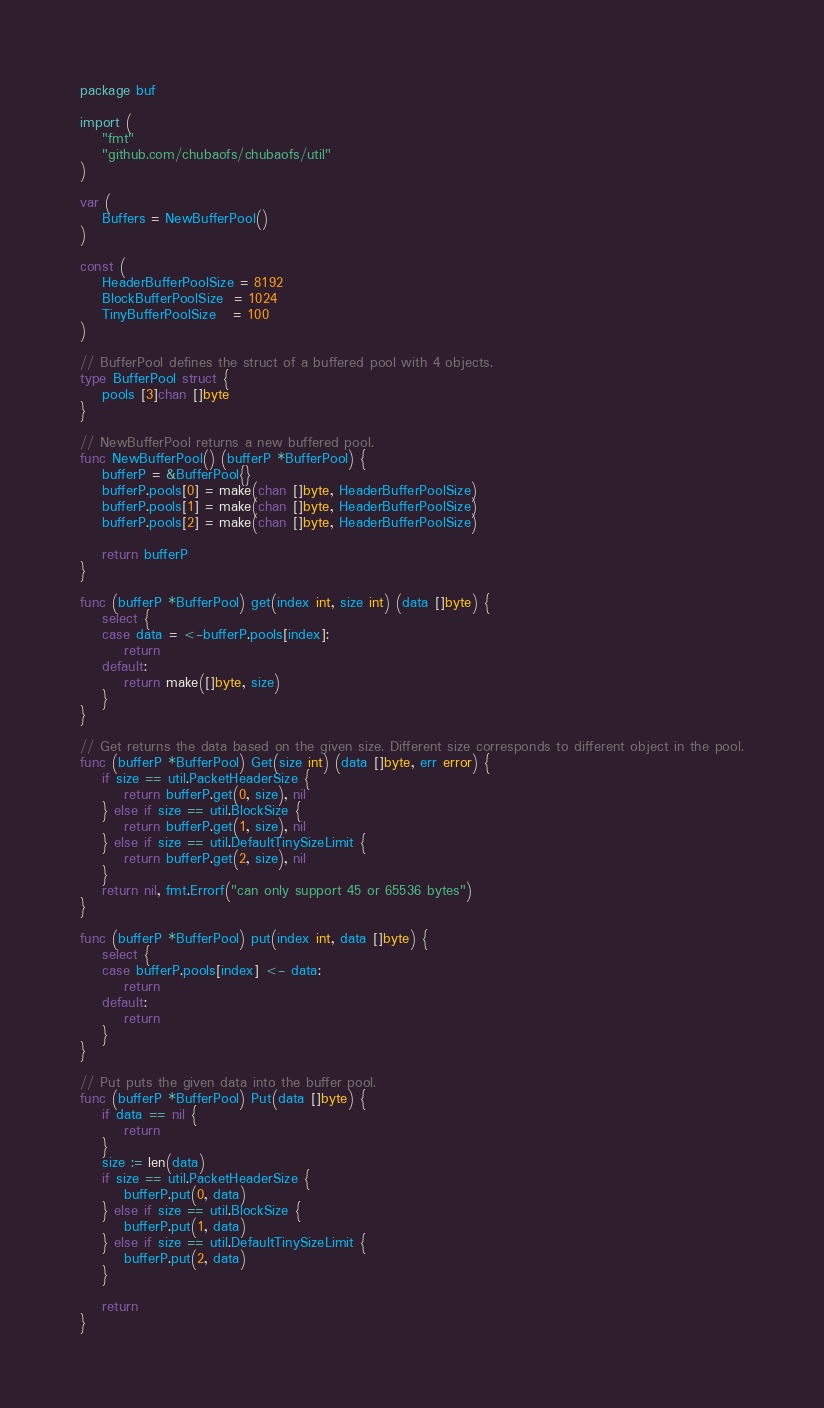Convert code to text. <code><loc_0><loc_0><loc_500><loc_500><_Go_>package buf

import (
	"fmt"
	"github.com/chubaofs/chubaofs/util"
)

var (
	Buffers = NewBufferPool()
)

const (
	HeaderBufferPoolSize = 8192
	BlockBufferPoolSize  = 1024
	TinyBufferPoolSize   = 100
)

// BufferPool defines the struct of a buffered pool with 4 objects.
type BufferPool struct {
	pools [3]chan []byte
}

// NewBufferPool returns a new buffered pool.
func NewBufferPool() (bufferP *BufferPool) {
	bufferP = &BufferPool{}
	bufferP.pools[0] = make(chan []byte, HeaderBufferPoolSize)
	bufferP.pools[1] = make(chan []byte, HeaderBufferPoolSize)
	bufferP.pools[2] = make(chan []byte, HeaderBufferPoolSize)

	return bufferP
}

func (bufferP *BufferPool) get(index int, size int) (data []byte) {
	select {
	case data = <-bufferP.pools[index]:
		return
	default:
		return make([]byte, size)
	}
}

// Get returns the data based on the given size. Different size corresponds to different object in the pool.
func (bufferP *BufferPool) Get(size int) (data []byte, err error) {
	if size == util.PacketHeaderSize {
		return bufferP.get(0, size), nil
	} else if size == util.BlockSize {
		return bufferP.get(1, size), nil
	} else if size == util.DefaultTinySizeLimit {
		return bufferP.get(2, size), nil
	}
	return nil, fmt.Errorf("can only support 45 or 65536 bytes")
}

func (bufferP *BufferPool) put(index int, data []byte) {
	select {
	case bufferP.pools[index] <- data:
		return
	default:
		return
	}
}

// Put puts the given data into the buffer pool.
func (bufferP *BufferPool) Put(data []byte) {
	if data == nil {
		return
	}
	size := len(data)
	if size == util.PacketHeaderSize {
		bufferP.put(0, data)
	} else if size == util.BlockSize {
		bufferP.put(1, data)
	} else if size == util.DefaultTinySizeLimit {
		bufferP.put(2, data)
	}

	return
}
</code> 